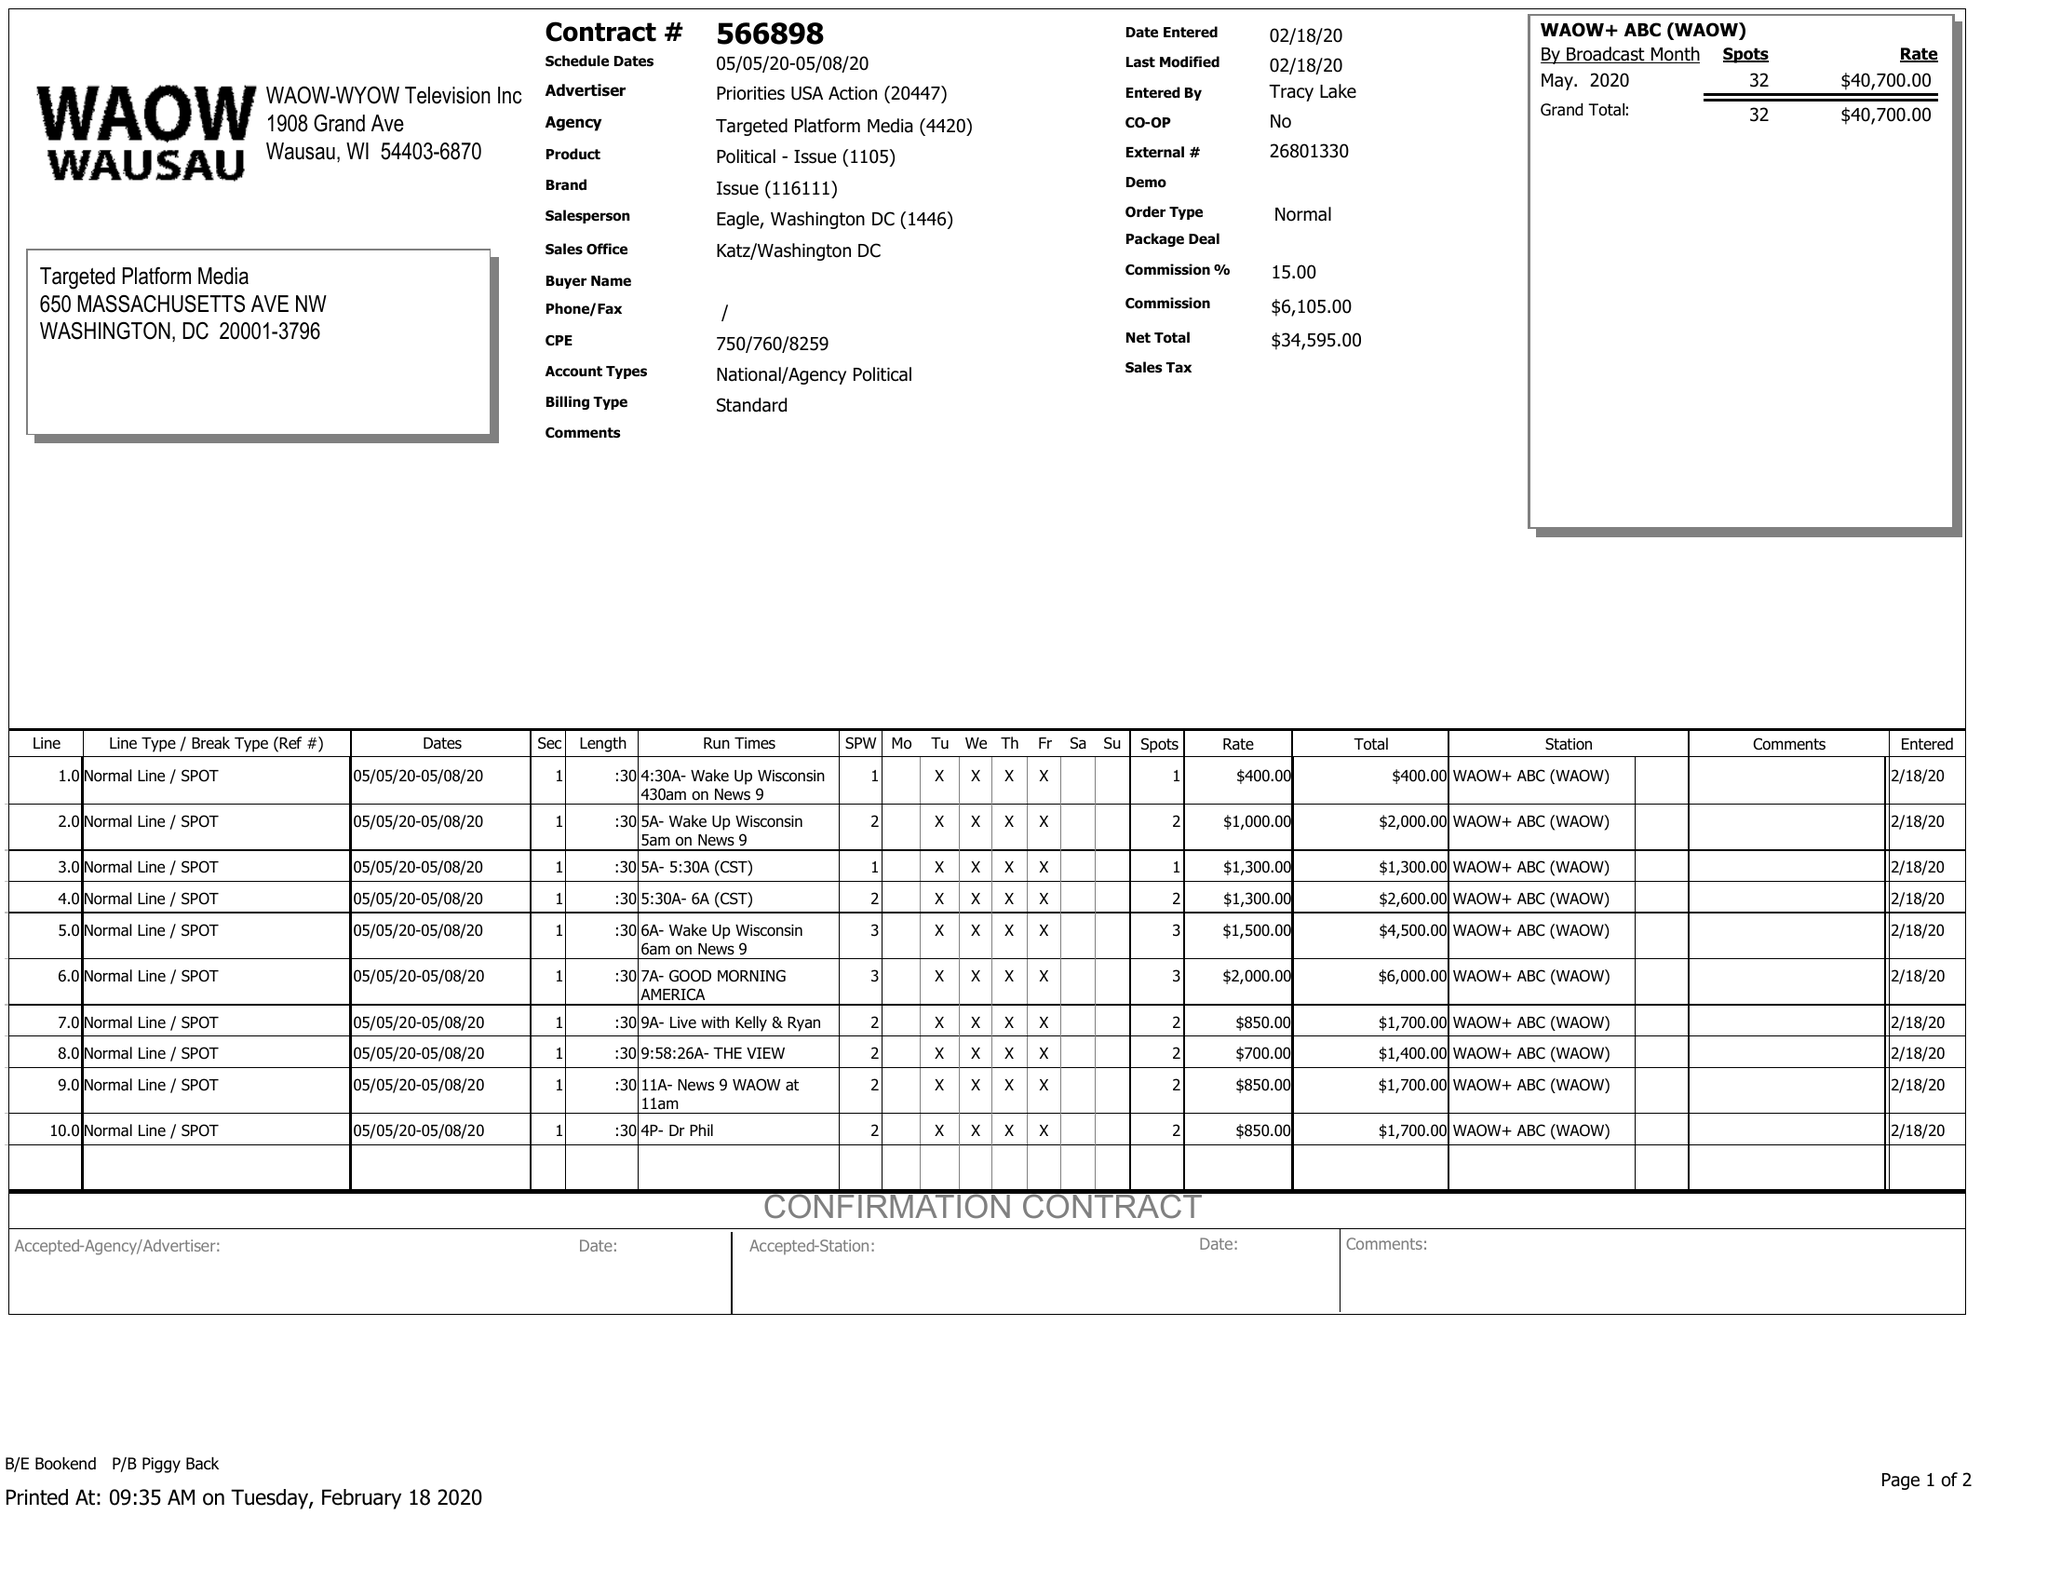What is the value for the gross_amount?
Answer the question using a single word or phrase. 40700.00 